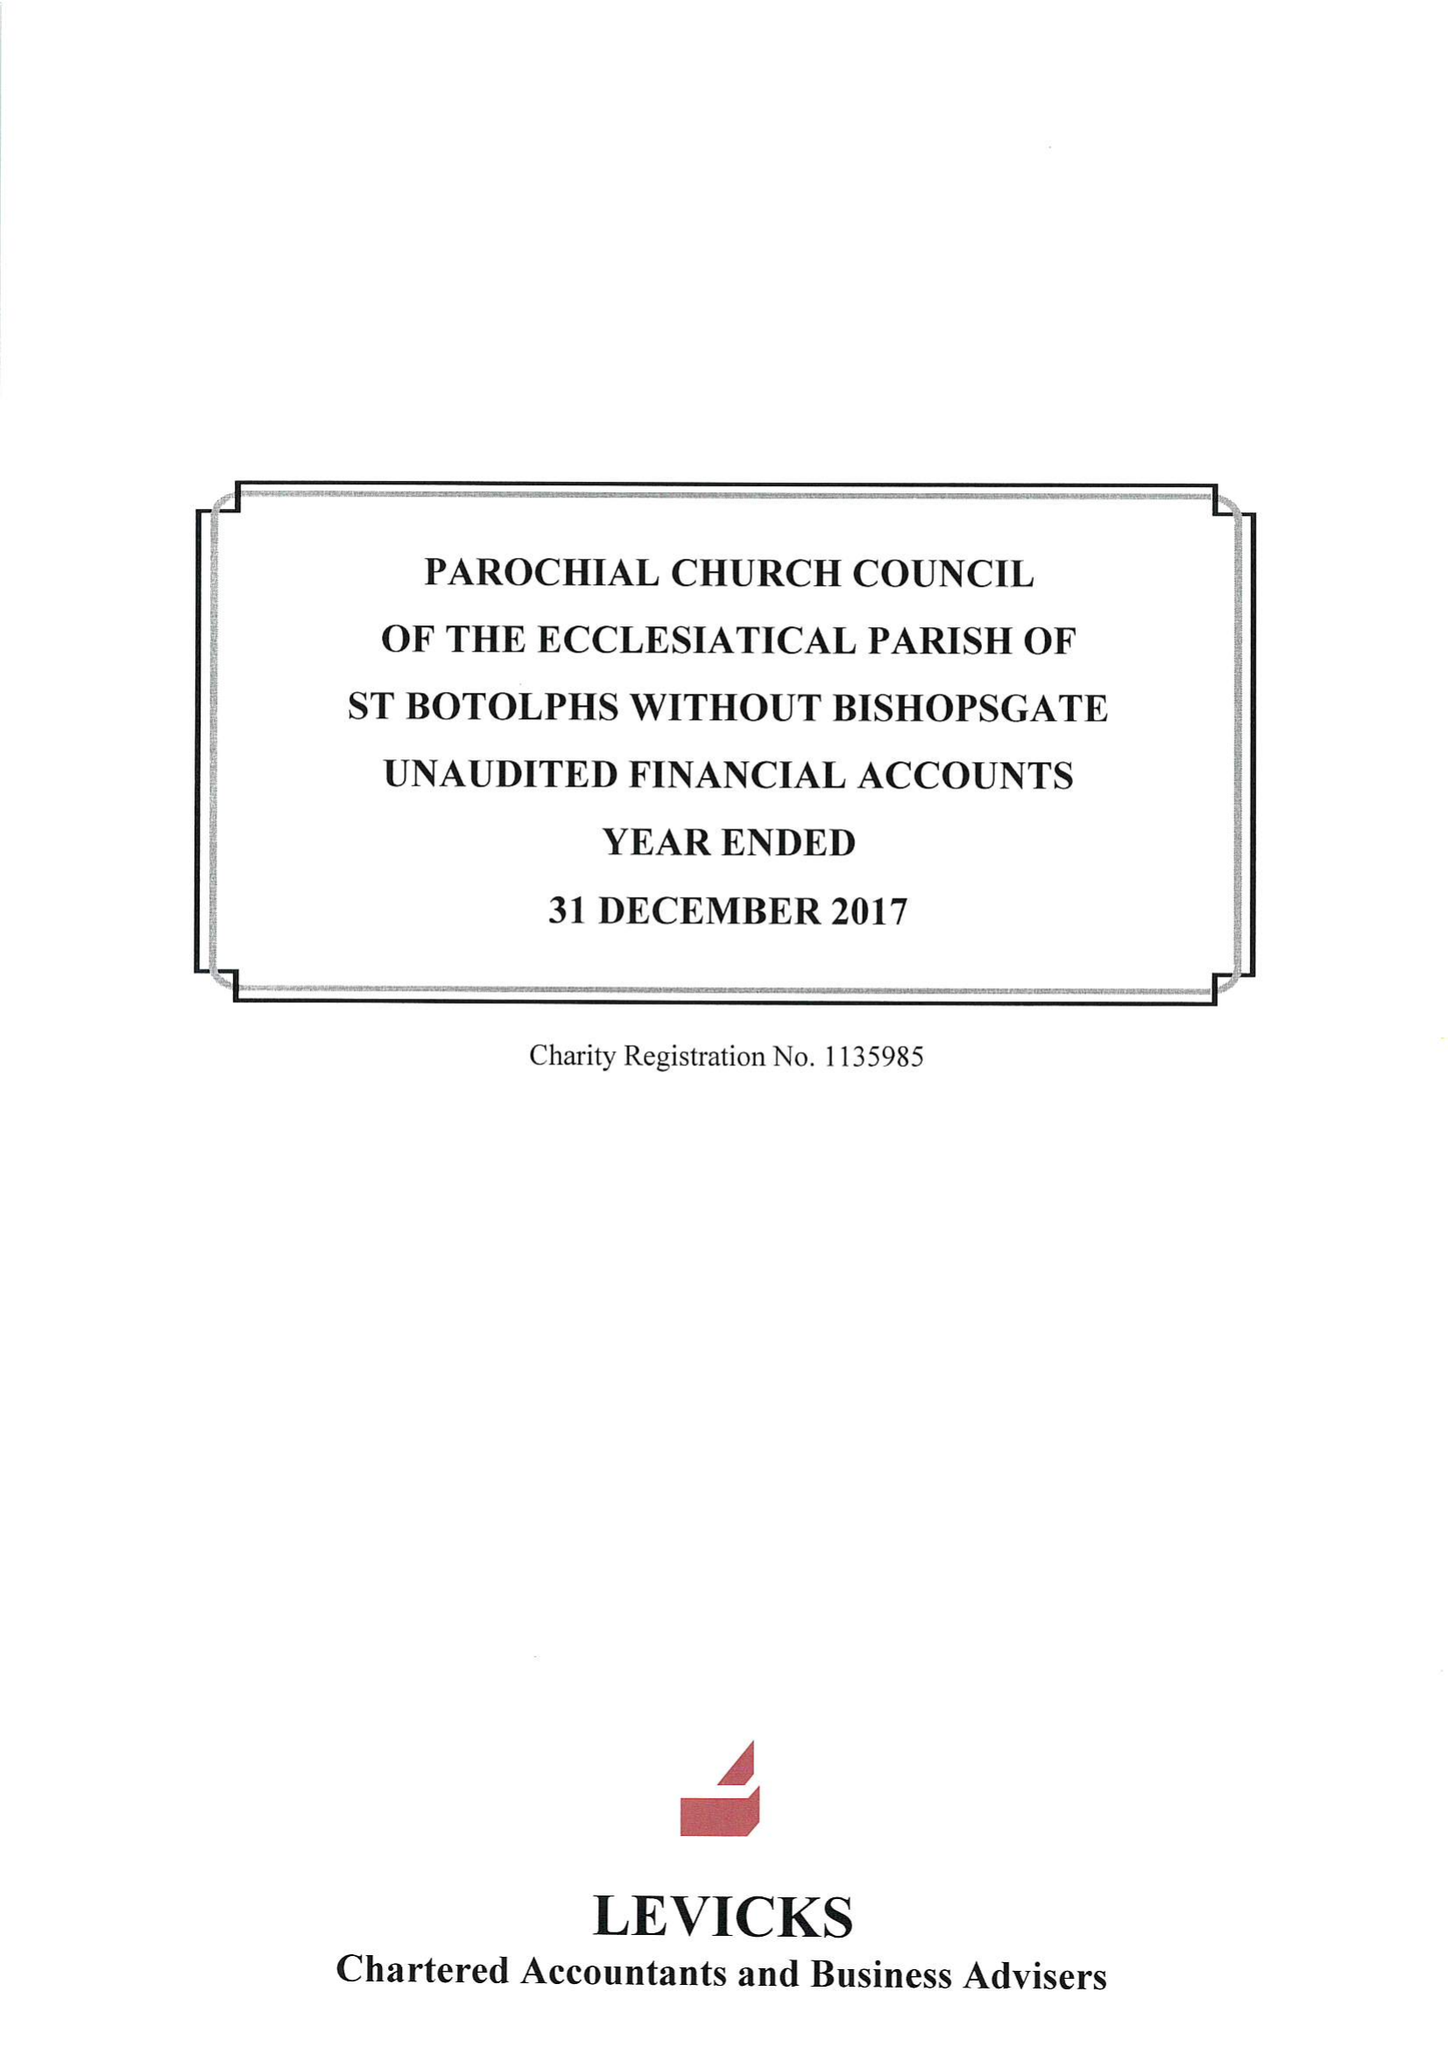What is the value for the charity_number?
Answer the question using a single word or phrase. 1135985 